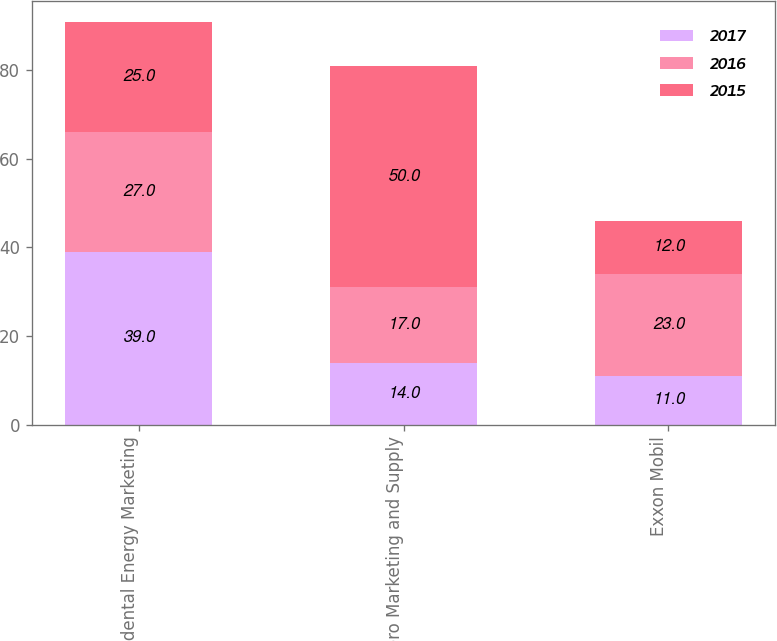Convert chart to OTSL. <chart><loc_0><loc_0><loc_500><loc_500><stacked_bar_chart><ecel><fcel>Occidental Energy Marketing<fcel>Valero Marketing and Supply<fcel>Exxon Mobil<nl><fcel>2017<fcel>39<fcel>14<fcel>11<nl><fcel>2016<fcel>27<fcel>17<fcel>23<nl><fcel>2015<fcel>25<fcel>50<fcel>12<nl></chart> 